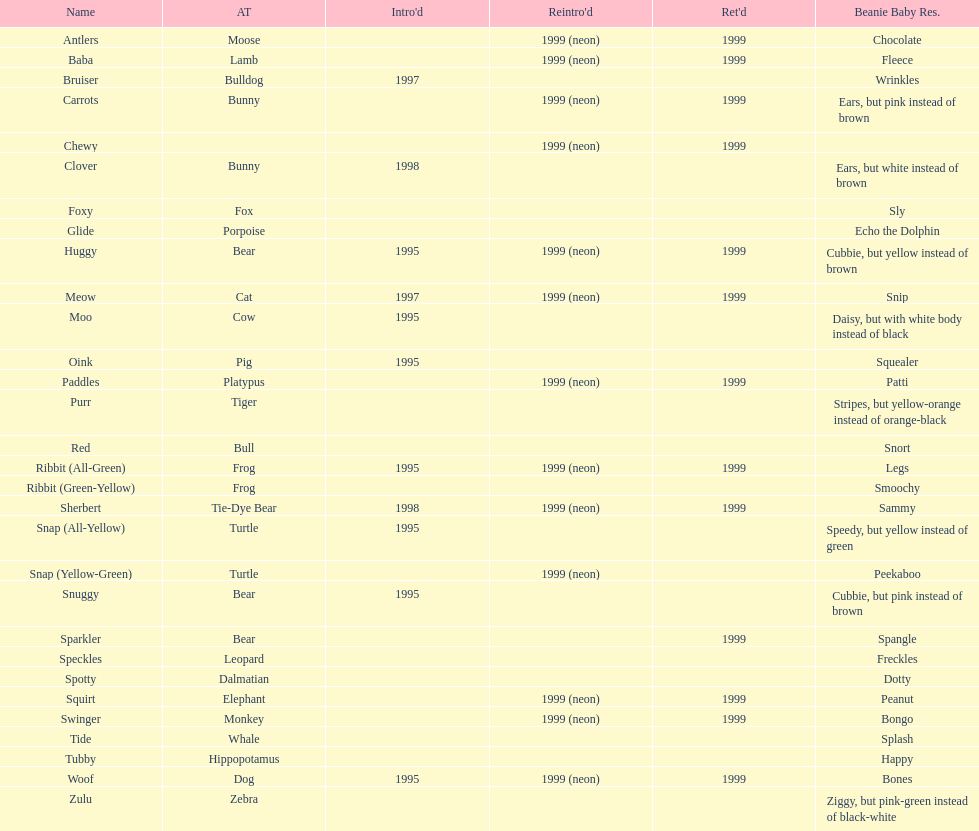Give me the full table as a dictionary. {'header': ['Name', 'AT', "Intro'd", "Reintro'd", "Ret'd", 'Beanie Baby Res.'], 'rows': [['Antlers', 'Moose', '', '1999 (neon)', '1999', 'Chocolate'], ['Baba', 'Lamb', '', '1999 (neon)', '1999', 'Fleece'], ['Bruiser', 'Bulldog', '1997', '', '', 'Wrinkles'], ['Carrots', 'Bunny', '', '1999 (neon)', '1999', 'Ears, but pink instead of brown'], ['Chewy', '', '', '1999 (neon)', '1999', ''], ['Clover', 'Bunny', '1998', '', '', 'Ears, but white instead of brown'], ['Foxy', 'Fox', '', '', '', 'Sly'], ['Glide', 'Porpoise', '', '', '', 'Echo the Dolphin'], ['Huggy', 'Bear', '1995', '1999 (neon)', '1999', 'Cubbie, but yellow instead of brown'], ['Meow', 'Cat', '1997', '1999 (neon)', '1999', 'Snip'], ['Moo', 'Cow', '1995', '', '', 'Daisy, but with white body instead of black'], ['Oink', 'Pig', '1995', '', '', 'Squealer'], ['Paddles', 'Platypus', '', '1999 (neon)', '1999', 'Patti'], ['Purr', 'Tiger', '', '', '', 'Stripes, but yellow-orange instead of orange-black'], ['Red', 'Bull', '', '', '', 'Snort'], ['Ribbit (All-Green)', 'Frog', '1995', '1999 (neon)', '1999', 'Legs'], ['Ribbit (Green-Yellow)', 'Frog', '', '', '', 'Smoochy'], ['Sherbert', 'Tie-Dye Bear', '1998', '1999 (neon)', '1999', 'Sammy'], ['Snap (All-Yellow)', 'Turtle', '1995', '', '', 'Speedy, but yellow instead of green'], ['Snap (Yellow-Green)', 'Turtle', '', '1999 (neon)', '', 'Peekaboo'], ['Snuggy', 'Bear', '1995', '', '', 'Cubbie, but pink instead of brown'], ['Sparkler', 'Bear', '', '', '1999', 'Spangle'], ['Speckles', 'Leopard', '', '', '', 'Freckles'], ['Spotty', 'Dalmatian', '', '', '', 'Dotty'], ['Squirt', 'Elephant', '', '1999 (neon)', '1999', 'Peanut'], ['Swinger', 'Monkey', '', '1999 (neon)', '1999', 'Bongo'], ['Tide', 'Whale', '', '', '', 'Splash'], ['Tubby', 'Hippopotamus', '', '', '', 'Happy'], ['Woof', 'Dog', '1995', '1999 (neon)', '1999', 'Bones'], ['Zulu', 'Zebra', '', '', '', 'Ziggy, but pink-green instead of black-white']]} What is the quantity of frog cushion friends? 2. 